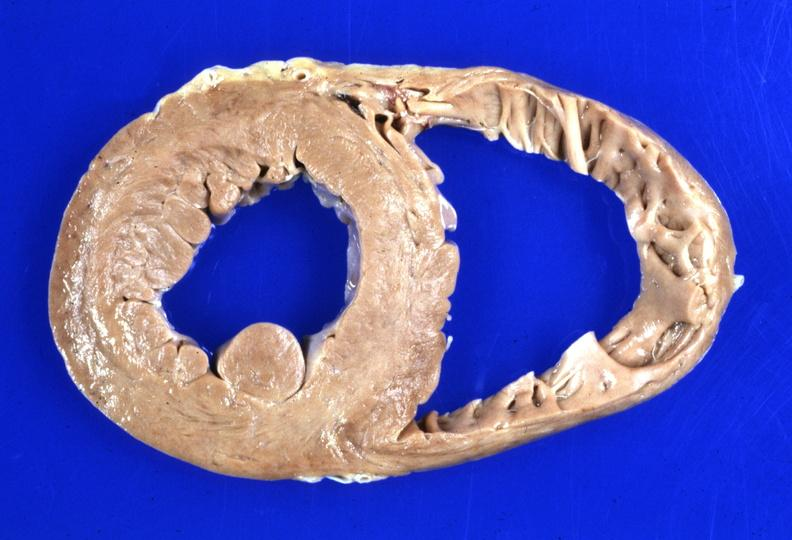what does this image show?
Answer the question using a single word or phrase. Heart dilation 